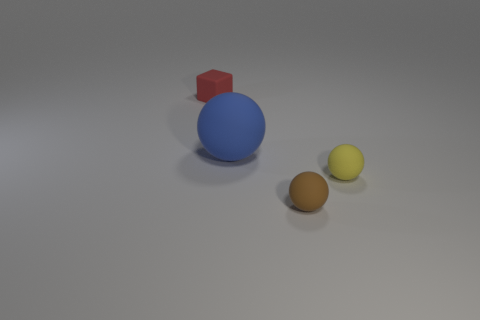Is there anything else that is the same shape as the red matte object?
Your answer should be compact. No. There is a small matte thing right of the brown matte object; is it the same shape as the large blue object that is behind the small brown rubber sphere?
Make the answer very short. Yes. What number of other things are there of the same color as the small block?
Provide a succinct answer. 0. What is the material of the small sphere that is behind the rubber object in front of the rubber ball that is to the right of the brown rubber ball?
Keep it short and to the point. Rubber. There is a tiny thing on the right side of the rubber ball that is in front of the yellow thing; what is it made of?
Your response must be concise. Rubber. Is the number of balls that are to the left of the small yellow thing less than the number of green rubber cubes?
Your answer should be compact. No. What shape is the small matte thing behind the tiny yellow matte object?
Your response must be concise. Cube. There is a blue matte object; is its size the same as the matte object behind the large blue matte ball?
Keep it short and to the point. No. Is there a big thing that has the same material as the brown sphere?
Provide a short and direct response. Yes. What number of blocks are either blue things or small brown objects?
Ensure brevity in your answer.  0. 